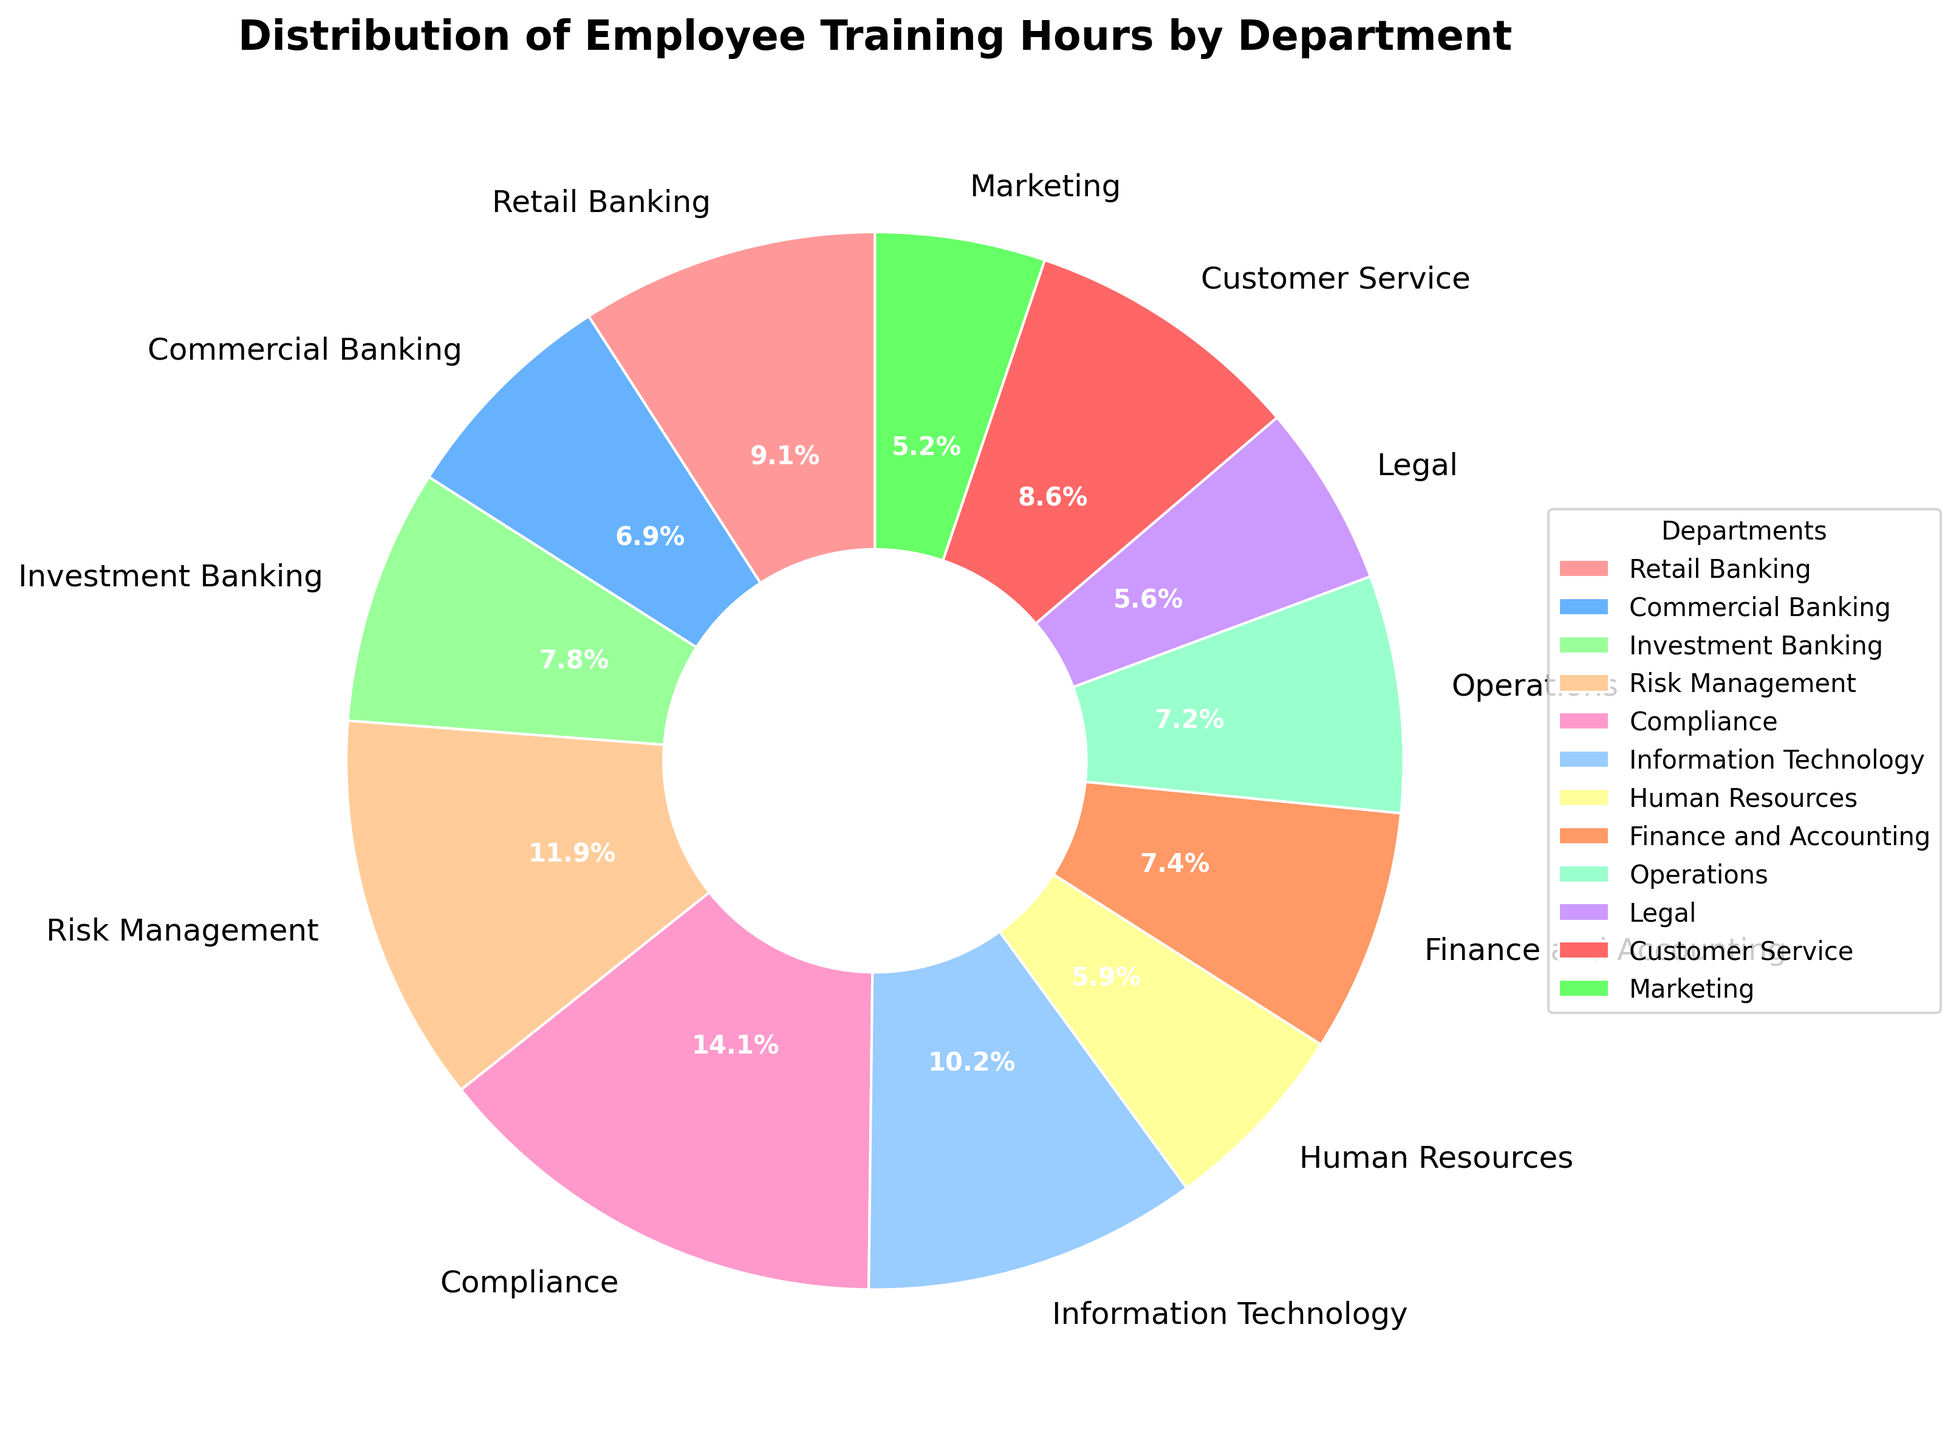What percentage of training hours does the Risk Management department have? Look at the slice labeled "Risk Management" in the pie chart, which shows the percentage for the department.
Answer: 14.4% Which departments have more training hours than Retail Banking? Compare the sizes of the pie slices and their corresponding percentages or labels. The slices for Compliance, Risk Management, and Information Technology are larger than that for Retail Banking.
Answer: Compliance, Risk Management, IT What's the combined training hours for Human Resources and Legal? Read the values for Human Resources (1600 hours) and Legal (1500 hours) and add them together. The sum is 1600 + 1500 = 3100.
Answer: 3100 How do the training hours in Customer Service compare to those in Operations? Look at the slices for Customer Service and Operations. Customer Service has 2300 hours and Operations has 1950 hours, so Customer Service has more training hours.
Answer: Customer Service has more What's the largest department in terms of training hours? Identify the largest pie slice. Compliance has the largest section of the pie chart.
Answer: Compliance Are the training hours for Marketing higher or lower than those for Finance and Accounting? Compare the slices labeled Marketing (1400 hours) and Finance and Accounting (2000 hours); Marketing's slice is smaller.
Answer: Lower What is the percentage difference in training hours between Information Technology and Finance and Accounting? Find the difference between Information Technology (2750 hours) and Finance and Accounting (2000 hours). Calculate the percentage difference: (2750 - 2000) / 2000 * 100.
Answer: 37.5% How much more training hours does Compliance have compared to Investment Banking? Retrieve the hours for Compliance (3800) and Investment Banking (2100). Subtract the Investment Banking hours from Compliance hours, 3800 - 2100 = 1700.
Answer: 1700 Which slice in the pie chart is represented with a green color? Look for the label corresponding to the green color in the pie chart slices, which is used as the color for Investment Banking.
Answer: Investment Banking Considering departments with at least 2000 training hours, what is the average training hours per department? The relevant departments are Retail Banking (2450), Investment Banking (2100), Compliance (3800), IT (2750), Finance and Accounting (2000), and Customer Service (2300). Sum these values: (2450 + 2100 + 3800 + 2750 + 2000 + 2300) = 15400. There are 6 departments, so the average is 15400 / 6.
Answer: 2566.7 